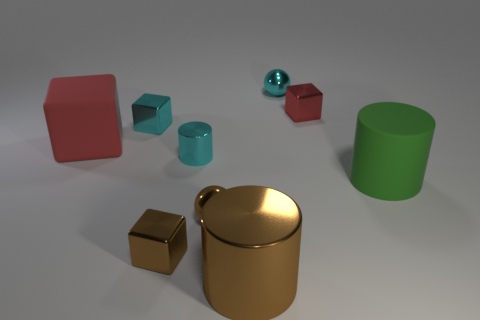Subtract all red cubes. How many were subtracted if there are1red cubes left? 1 Subtract all blocks. How many objects are left? 5 Add 7 tiny spheres. How many tiny spheres exist? 9 Subtract 1 cyan spheres. How many objects are left? 8 Subtract all tiny brown blocks. Subtract all green matte objects. How many objects are left? 7 Add 4 small cyan shiny cubes. How many small cyan shiny cubes are left? 5 